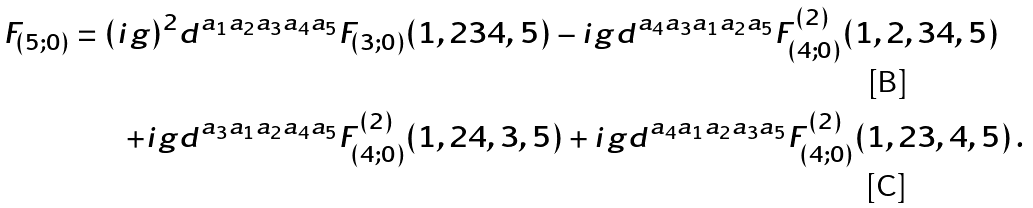Convert formula to latex. <formula><loc_0><loc_0><loc_500><loc_500>F _ { ( 5 ; 0 ) } = ( i g ) ^ { 2 } & d ^ { a _ { 1 } a _ { 2 } a _ { 3 } a _ { 4 } a _ { 5 } } F _ { ( 3 ; 0 ) } ( 1 , 2 3 4 , 5 ) - i g d ^ { a _ { 4 } a _ { 3 } a _ { 1 } a _ { 2 } a _ { 5 } } F _ { ( 4 ; 0 ) } ^ { ( 2 ) } ( 1 , 2 , 3 4 , 5 ) \\ + i g & d ^ { a _ { 3 } a _ { 1 } a _ { 2 } a _ { 4 } a _ { 5 } } F _ { ( 4 ; 0 ) } ^ { ( 2 ) } ( 1 , 2 4 , 3 , 5 ) + i g d ^ { a _ { 4 } a _ { 1 } a _ { 2 } a _ { 3 } a _ { 5 } } F _ { ( 4 ; 0 ) } ^ { ( 2 ) } ( 1 , 2 3 , 4 , 5 ) \, .</formula> 